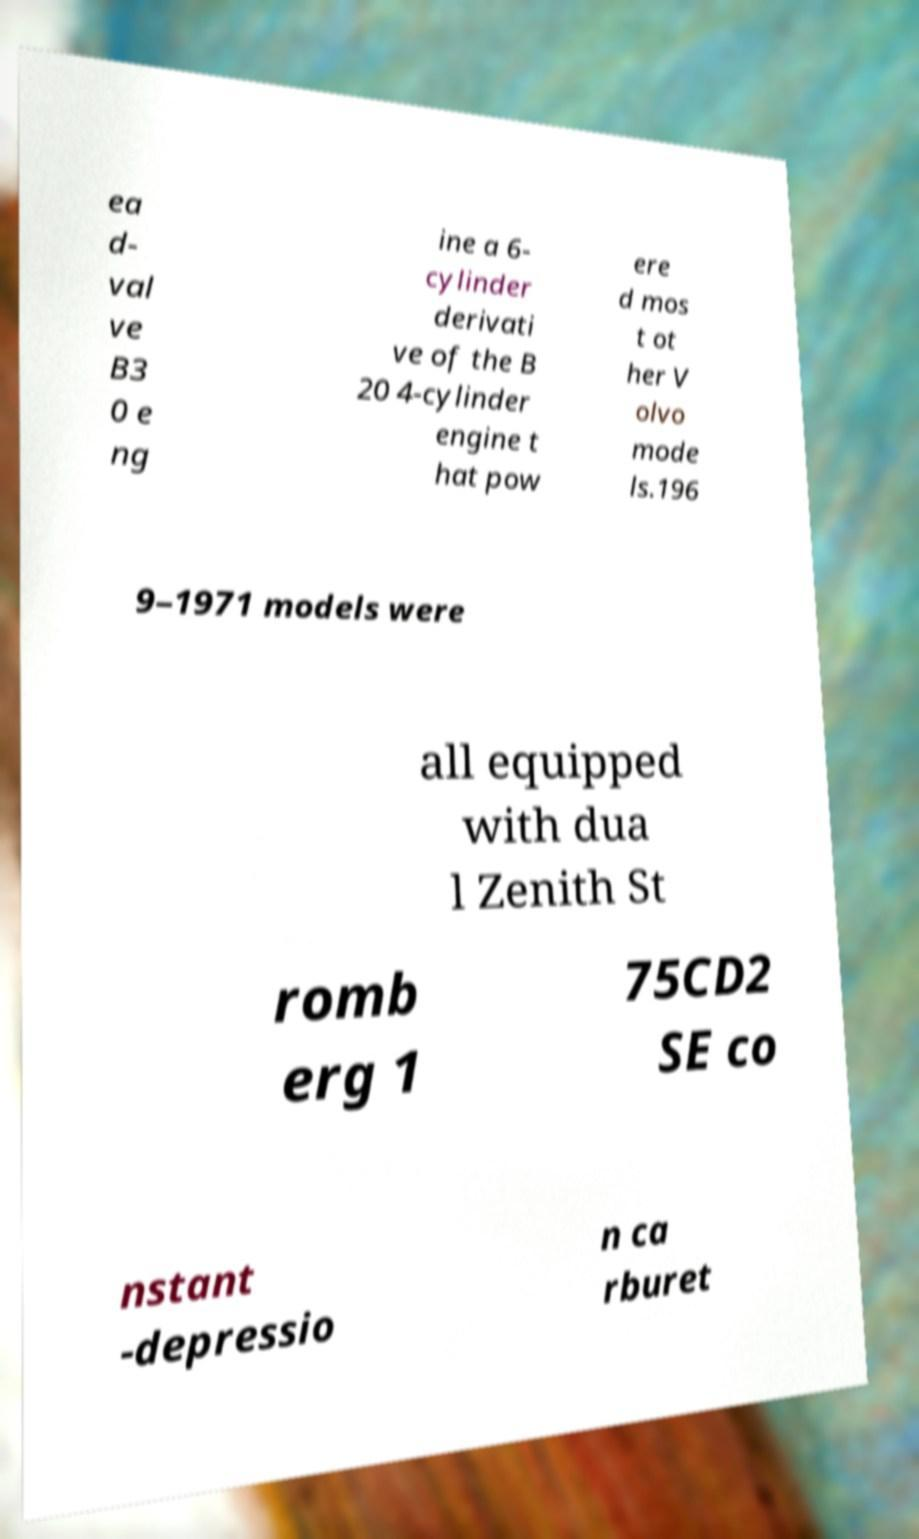What messages or text are displayed in this image? I need them in a readable, typed format. ea d- val ve B3 0 e ng ine a 6- cylinder derivati ve of the B 20 4-cylinder engine t hat pow ere d mos t ot her V olvo mode ls.196 9–1971 models were all equipped with dua l Zenith St romb erg 1 75CD2 SE co nstant -depressio n ca rburet 